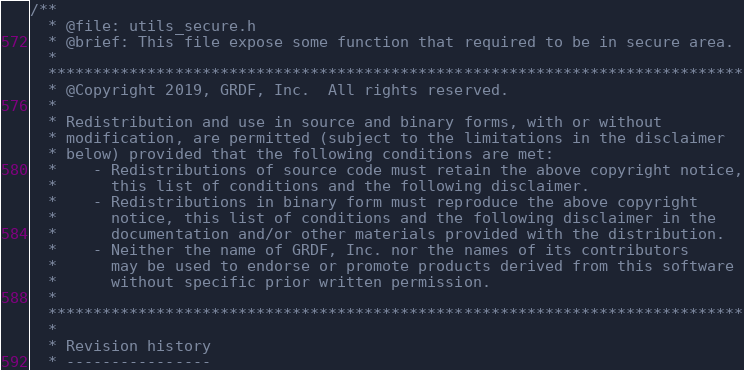<code> <loc_0><loc_0><loc_500><loc_500><_C_>/**
  * @file: utils_secure.h
  * @brief: This file expose some function that required to be in secure area.
  * 
  *****************************************************************************
  * @Copyright 2019, GRDF, Inc.  All rights reserved.
  *
  * Redistribution and use in source and binary forms, with or without 
  * modification, are permitted (subject to the limitations in the disclaimer
  * below) provided that the following conditions are met:
  *    - Redistributions of source code must retain the above copyright notice,
  *      this list of conditions and the following disclaimer.
  *    - Redistributions in binary form must reproduce the above copyright 
  *      notice, this list of conditions and the following disclaimer in the 
  *      documentation and/or other materials provided with the distribution.
  *    - Neither the name of GRDF, Inc. nor the names of its contributors
  *      may be used to endorse or promote products derived from this software
  *      without specific prior written permission.
  *
  *****************************************************************************
  *
  * Revision history
  * ----------------</code> 